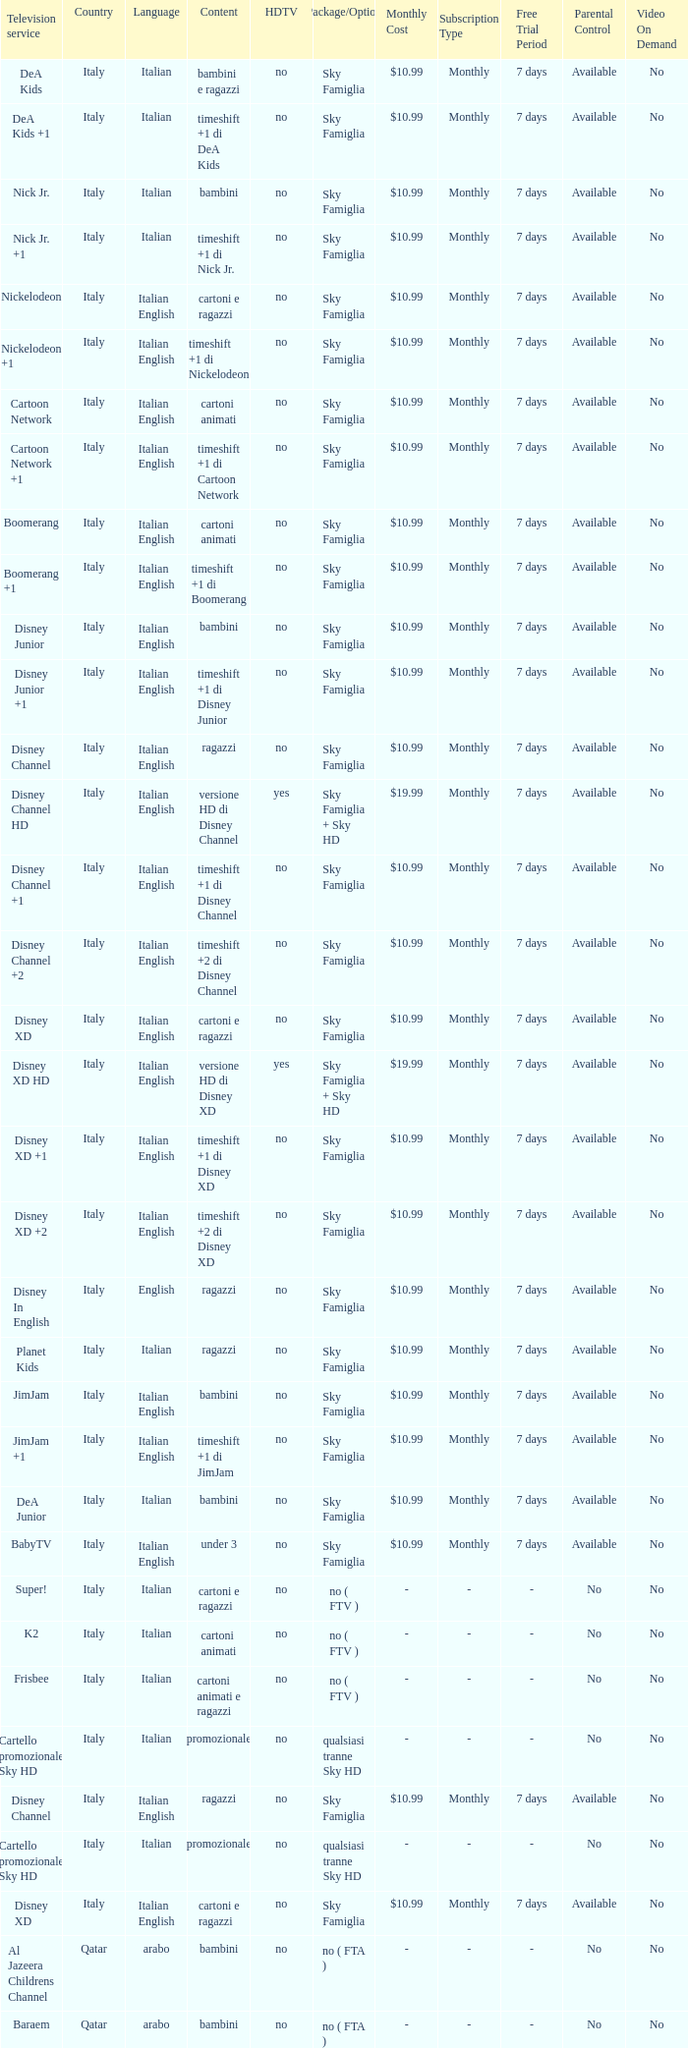What is the HDTV when the content shows a timeshift +1 di disney junior? No. 